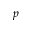Convert formula to latex. <formula><loc_0><loc_0><loc_500><loc_500>p</formula> 